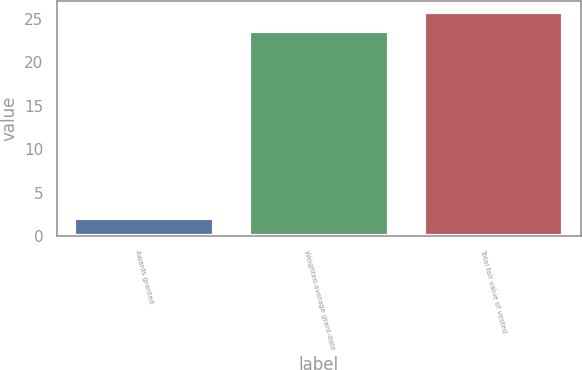Convert chart. <chart><loc_0><loc_0><loc_500><loc_500><bar_chart><fcel>Awards granted<fcel>Weighted-average grant-date<fcel>Total fair value of vested<nl><fcel>2.1<fcel>23.6<fcel>25.81<nl></chart> 